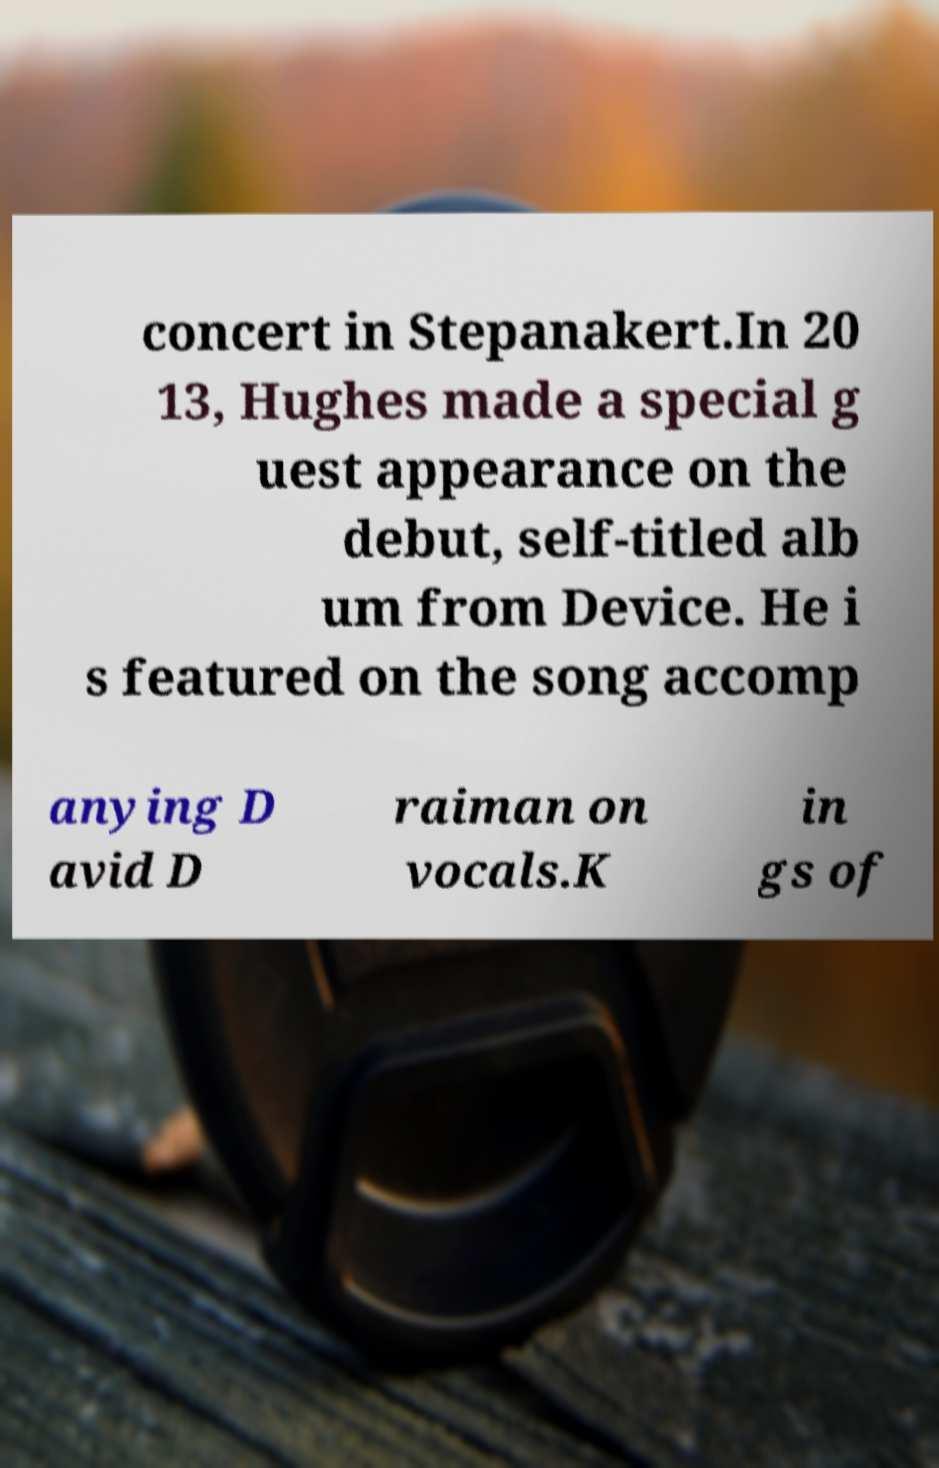Could you assist in decoding the text presented in this image and type it out clearly? concert in Stepanakert.In 20 13, Hughes made a special g uest appearance on the debut, self-titled alb um from Device. He i s featured on the song accomp anying D avid D raiman on vocals.K in gs of 